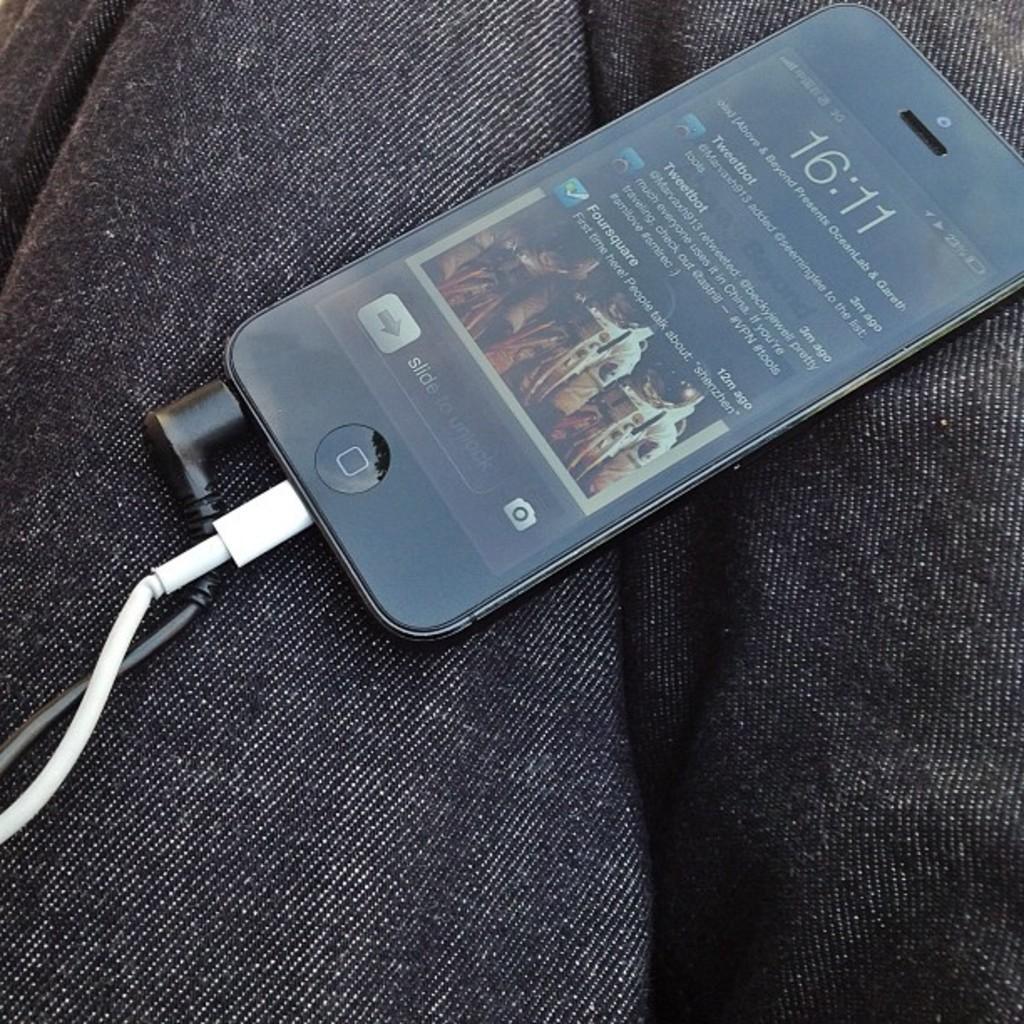How would you summarize this image in a sentence or two? In this image, we can see a mobile phone with wires is placed on some cloth. 